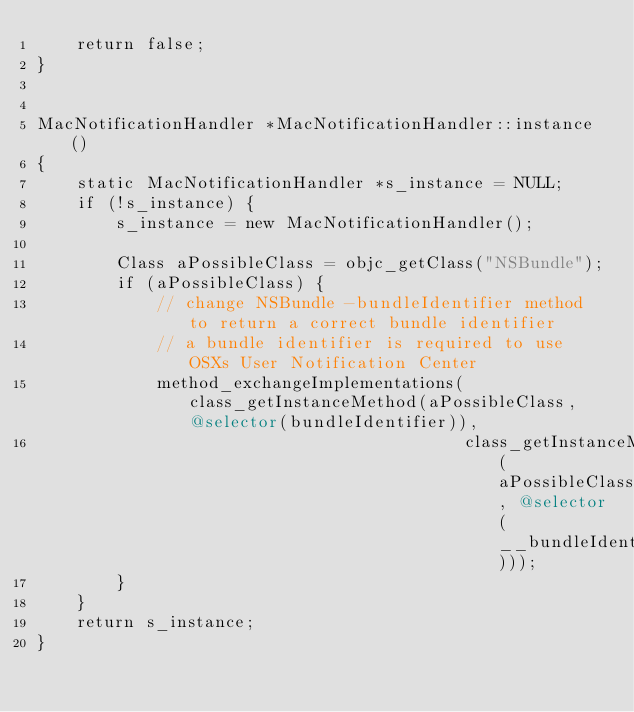Convert code to text. <code><loc_0><loc_0><loc_500><loc_500><_ObjectiveC_>    return false;
}


MacNotificationHandler *MacNotificationHandler::instance()
{
    static MacNotificationHandler *s_instance = NULL;
    if (!s_instance) {
        s_instance = new MacNotificationHandler();
        
        Class aPossibleClass = objc_getClass("NSBundle");
        if (aPossibleClass) {
            // change NSBundle -bundleIdentifier method to return a correct bundle identifier
            // a bundle identifier is required to use OSXs User Notification Center
            method_exchangeImplementations(class_getInstanceMethod(aPossibleClass, @selector(bundleIdentifier)),
                                           class_getInstanceMethod(aPossibleClass, @selector(__bundleIdentifier)));
        }
    }
    return s_instance;
}
</code> 